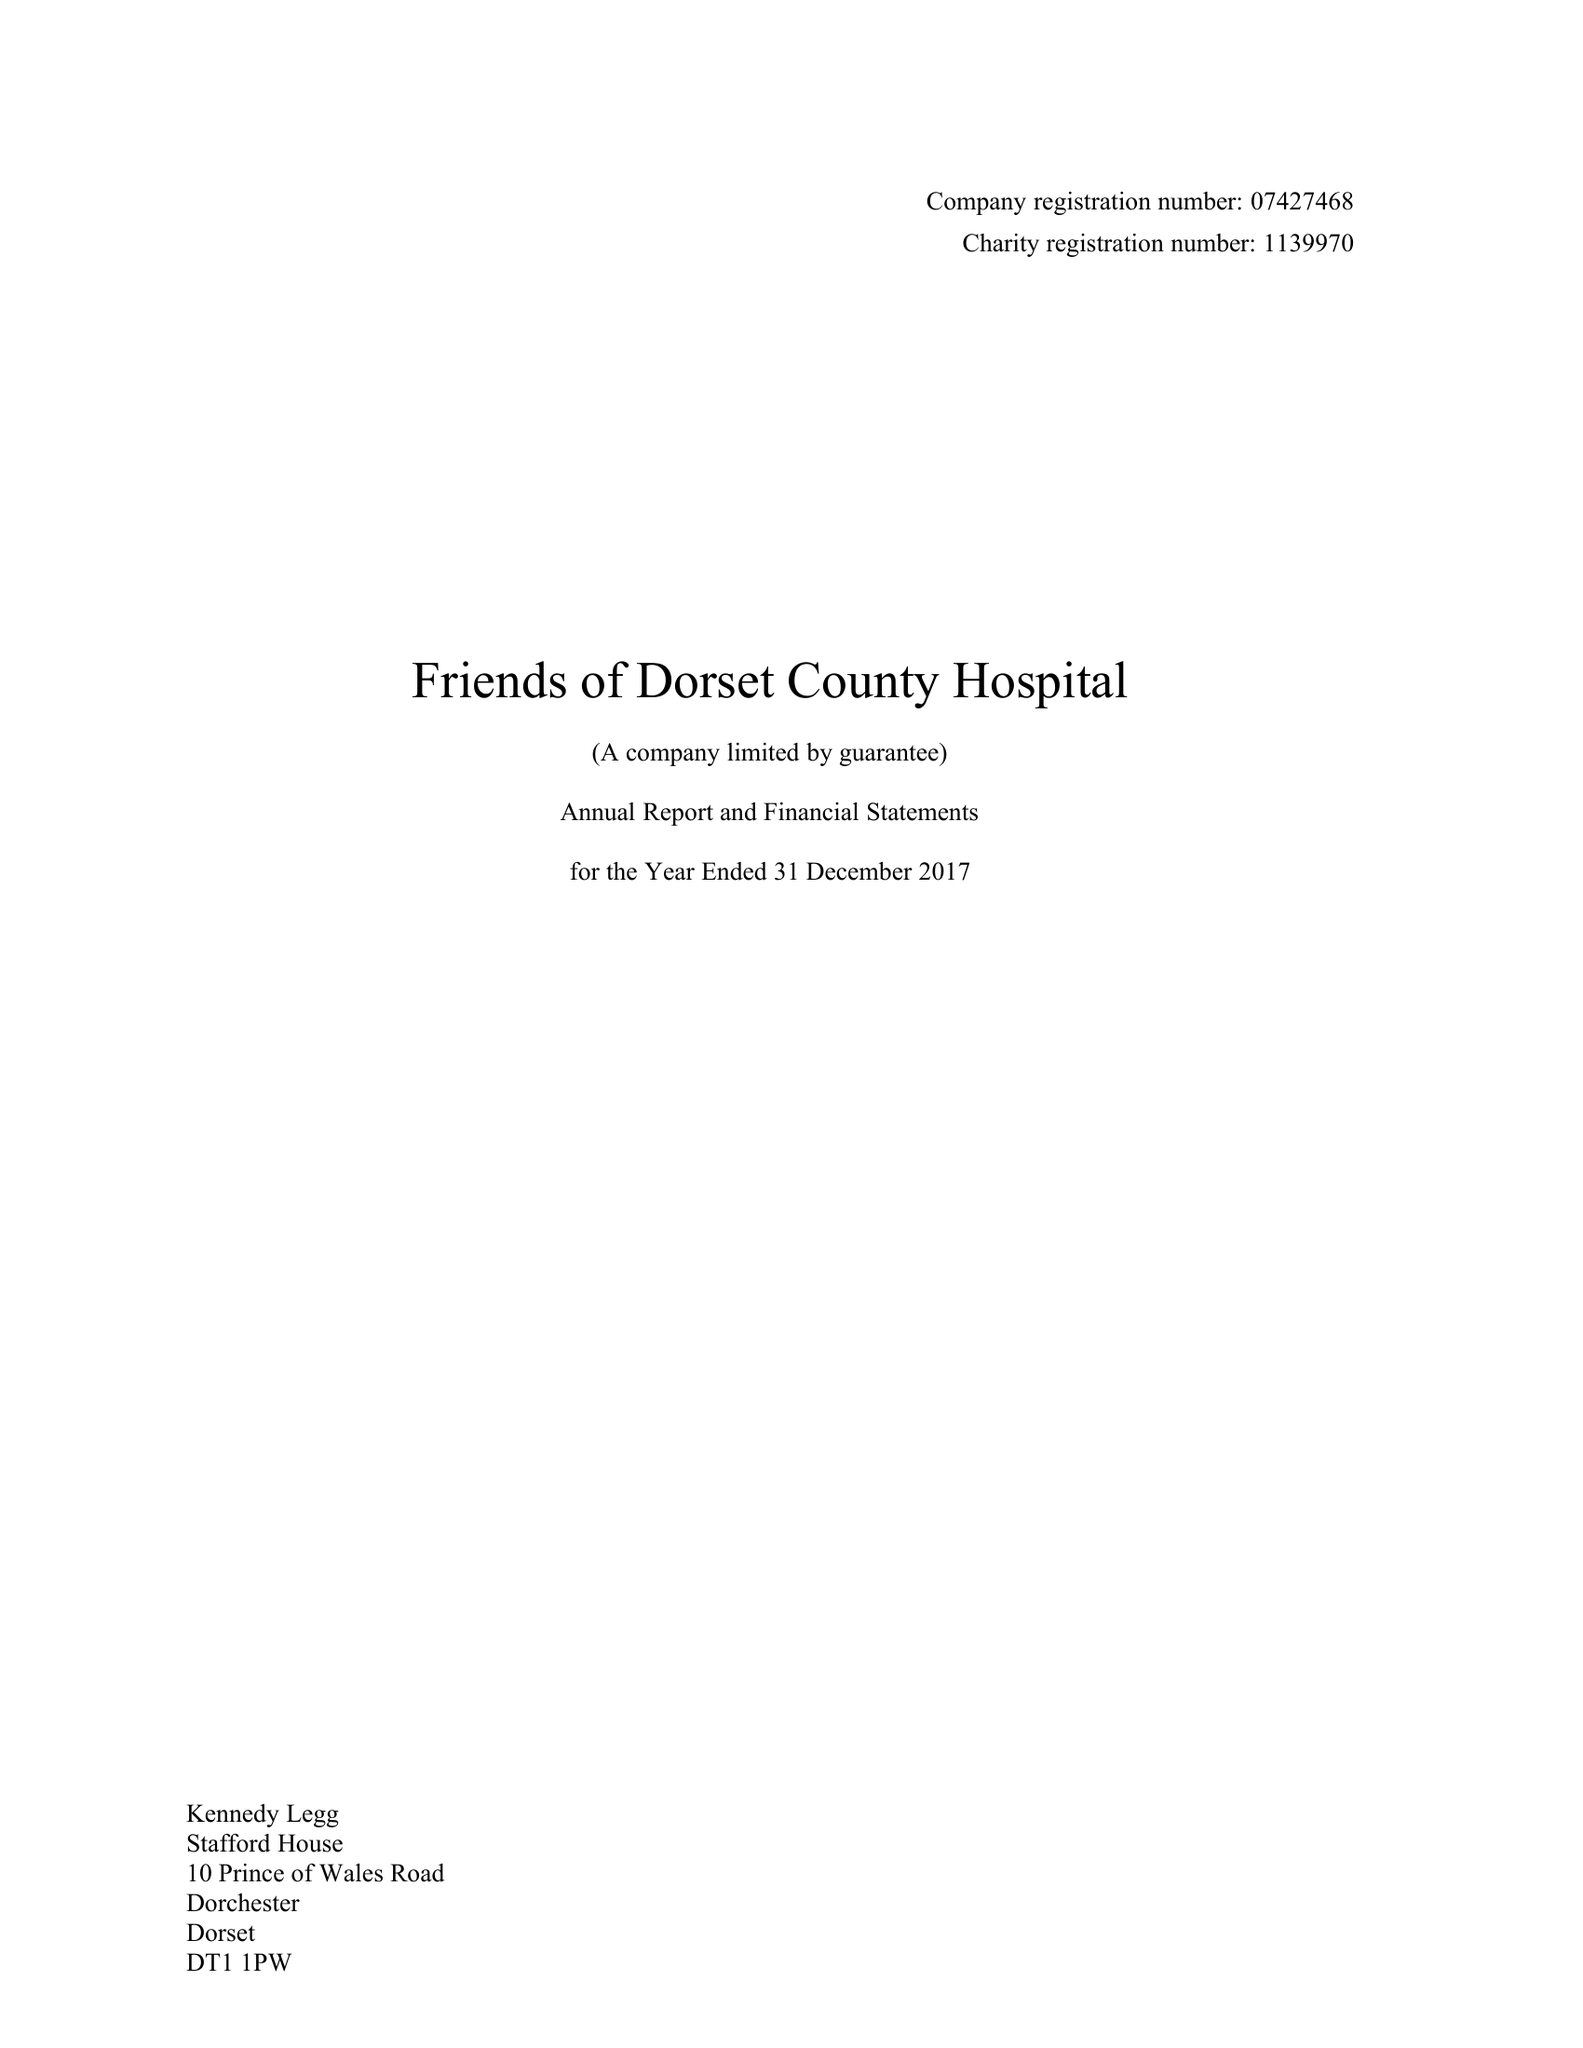What is the value for the income_annually_in_british_pounds?
Answer the question using a single word or phrase. 160675.00 